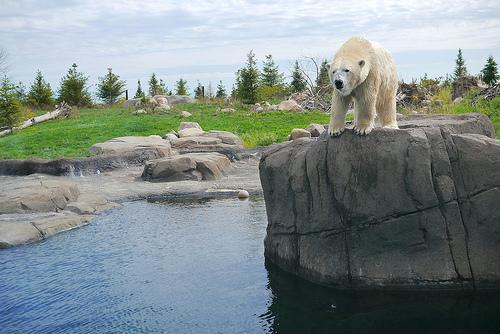How many bears are in the picture?
Give a very brief answer. 1. 